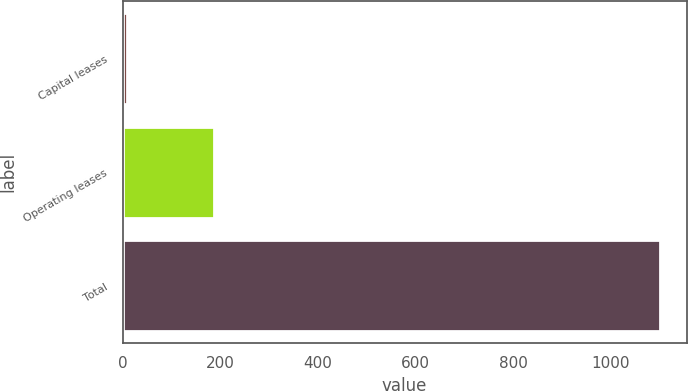<chart> <loc_0><loc_0><loc_500><loc_500><bar_chart><fcel>Capital leases<fcel>Operating leases<fcel>Total<nl><fcel>8<fcel>188.1<fcel>1099.9<nl></chart> 